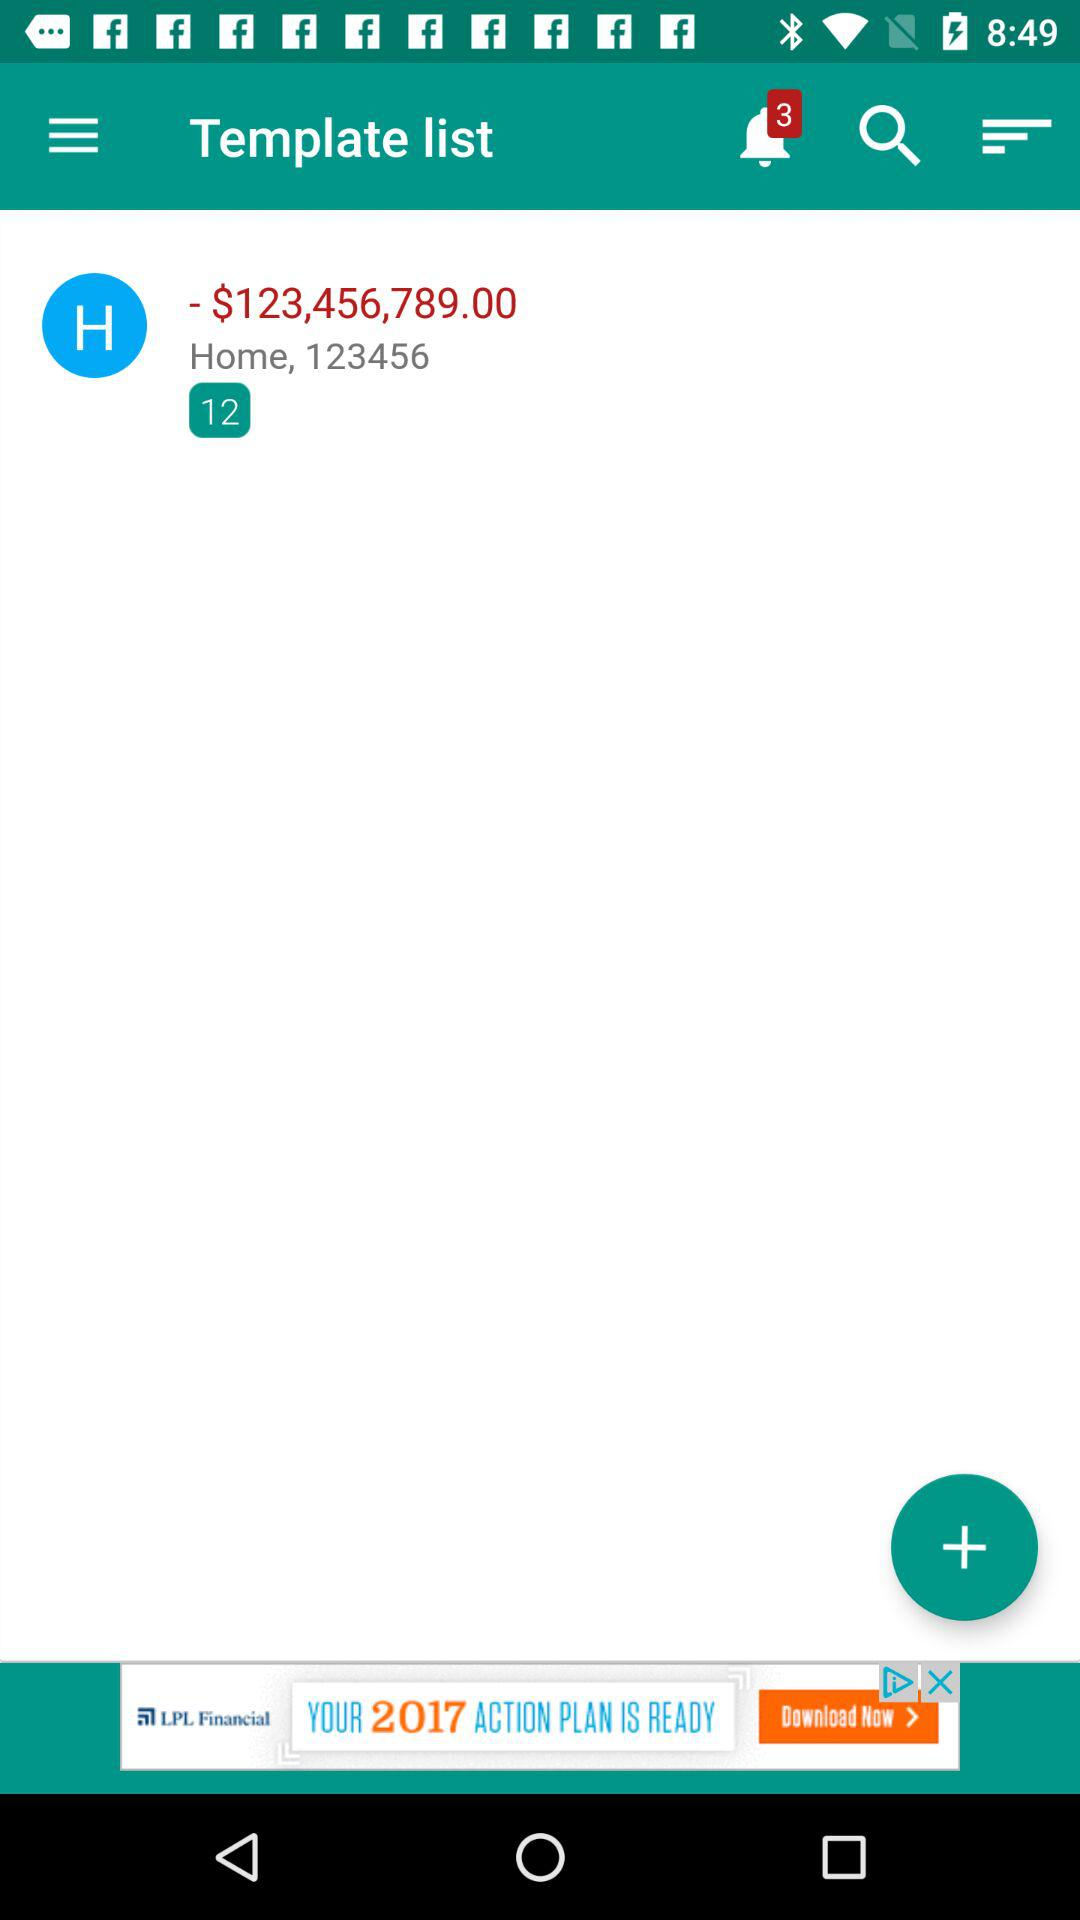How much is the total value of all the invoices?
Answer the question using a single word or phrase. $123,456,789.00 